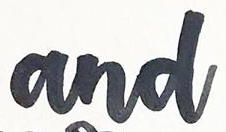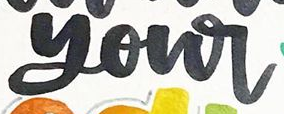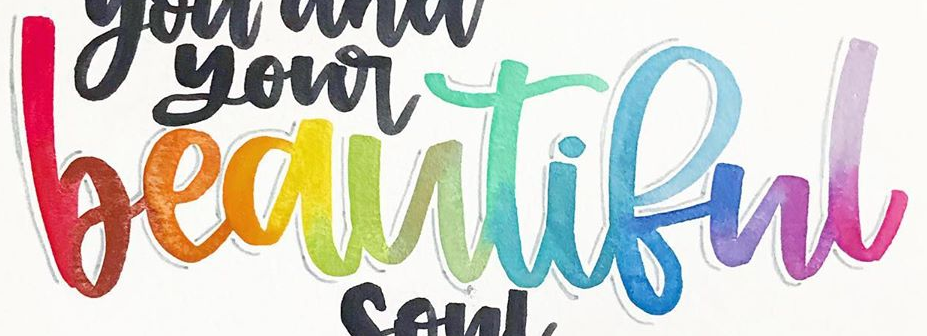What words can you see in these images in sequence, separated by a semicolon? and; your; beautiful 